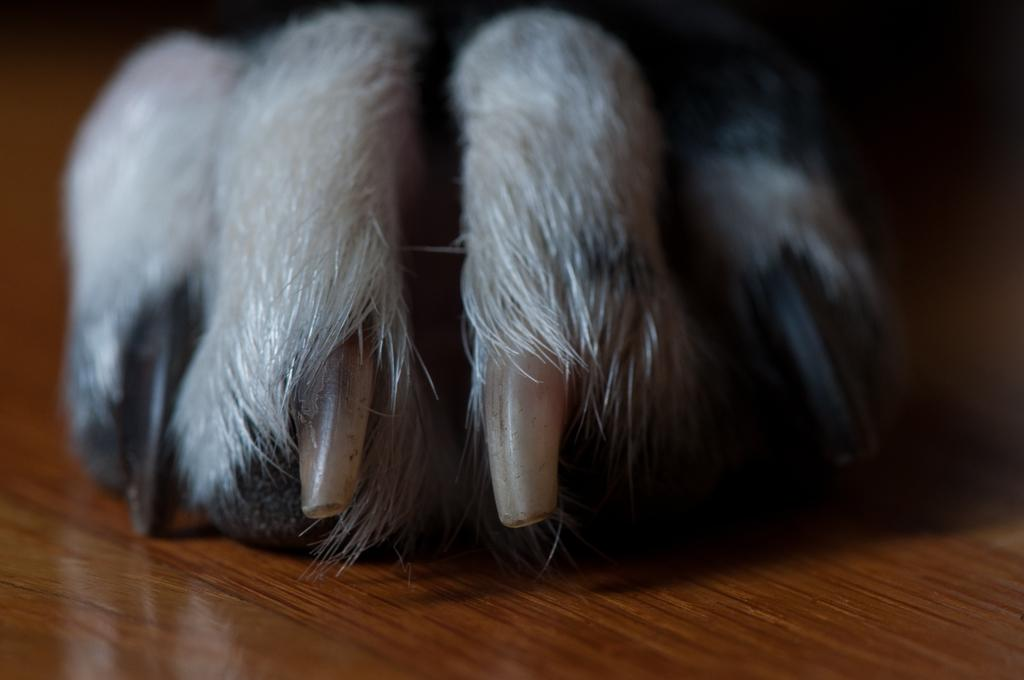What is the main subject of the image? The main subject of the image is a leg of an animal. On what surface is the animal leg placed? The leg is on a wooden surface. What type of advertisement is displayed on the wooden surface in the image? There is no advertisement present in the image; it only features a leg of an animal on a wooden surface. What scientific experiment is being conducted with the animal leg in the image? There is no scientific experiment being conducted in the image; it only features a leg of an animal on a wooden surface. 